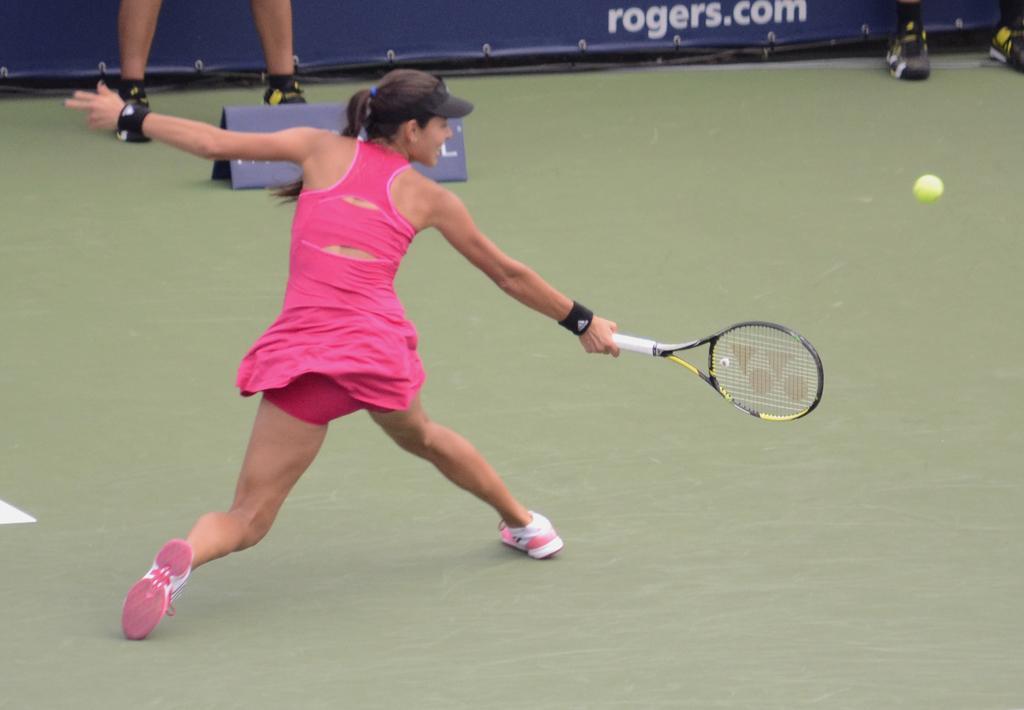Describe this image in one or two sentences. There is a ground. In this ground she plays tennis. She wearing cap. On the left side we have a person. We can see in background banner and ground. 